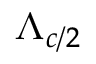Convert formula to latex. <formula><loc_0><loc_0><loc_500><loc_500>\Lambda _ { c / 2 }</formula> 